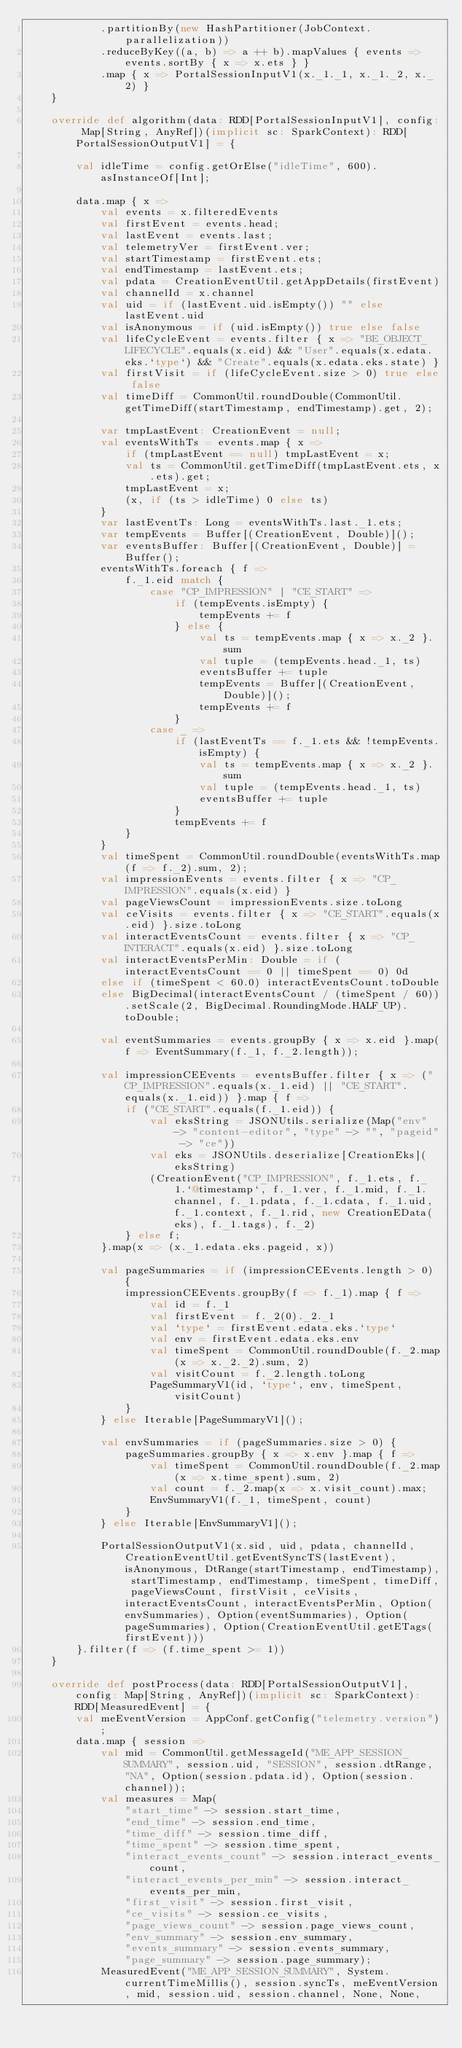Convert code to text. <code><loc_0><loc_0><loc_500><loc_500><_Scala_>            .partitionBy(new HashPartitioner(JobContext.parallelization))
            .reduceByKey((a, b) => a ++ b).mapValues { events => events.sortBy { x => x.ets } }
            .map { x => PortalSessionInputV1(x._1._1, x._1._2, x._2) }
    }

    override def algorithm(data: RDD[PortalSessionInputV1], config: Map[String, AnyRef])(implicit sc: SparkContext): RDD[PortalSessionOutputV1] = {

        val idleTime = config.getOrElse("idleTime", 600).asInstanceOf[Int];

        data.map { x =>
            val events = x.filteredEvents
            val firstEvent = events.head;
            val lastEvent = events.last;
            val telemetryVer = firstEvent.ver;
            val startTimestamp = firstEvent.ets;
            val endTimestamp = lastEvent.ets;
            val pdata = CreationEventUtil.getAppDetails(firstEvent)
            val channelId = x.channel
            val uid = if (lastEvent.uid.isEmpty()) "" else lastEvent.uid
            val isAnonymous = if (uid.isEmpty()) true else false
            val lifeCycleEvent = events.filter { x => "BE_OBJECT_LIFECYCLE".equals(x.eid) && "User".equals(x.edata.eks.`type`) && "Create".equals(x.edata.eks.state) }
            val firstVisit = if (lifeCycleEvent.size > 0) true else false
            val timeDiff = CommonUtil.roundDouble(CommonUtil.getTimeDiff(startTimestamp, endTimestamp).get, 2);

            var tmpLastEvent: CreationEvent = null;
            val eventsWithTs = events.map { x =>
                if (tmpLastEvent == null) tmpLastEvent = x;
                val ts = CommonUtil.getTimeDiff(tmpLastEvent.ets, x.ets).get;
                tmpLastEvent = x;
                (x, if (ts > idleTime) 0 else ts)
            }
            var lastEventTs: Long = eventsWithTs.last._1.ets;
            var tempEvents = Buffer[(CreationEvent, Double)]();
            var eventsBuffer: Buffer[(CreationEvent, Double)] = Buffer();
            eventsWithTs.foreach { f =>
                f._1.eid match {
                    case "CP_IMPRESSION" | "CE_START" =>
                        if (tempEvents.isEmpty) {
                            tempEvents += f
                        } else {
                            val ts = tempEvents.map { x => x._2 }.sum
                            val tuple = (tempEvents.head._1, ts)
                            eventsBuffer += tuple
                            tempEvents = Buffer[(CreationEvent, Double)]();
                            tempEvents += f
                        }
                    case _ =>
                        if (lastEventTs == f._1.ets && !tempEvents.isEmpty) {
                            val ts = tempEvents.map { x => x._2 }.sum
                            val tuple = (tempEvents.head._1, ts)
                            eventsBuffer += tuple
                        }
                        tempEvents += f
                }
            }
            val timeSpent = CommonUtil.roundDouble(eventsWithTs.map(f => f._2).sum, 2);
            val impressionEvents = events.filter { x => "CP_IMPRESSION".equals(x.eid) }
            val pageViewsCount = impressionEvents.size.toLong
            val ceVisits = events.filter { x => "CE_START".equals(x.eid) }.size.toLong
            val interactEventsCount = events.filter { x => "CP_INTERACT".equals(x.eid) }.size.toLong
            val interactEventsPerMin: Double = if (interactEventsCount == 0 || timeSpent == 0) 0d
            else if (timeSpent < 60.0) interactEventsCount.toDouble
            else BigDecimal(interactEventsCount / (timeSpent / 60)).setScale(2, BigDecimal.RoundingMode.HALF_UP).toDouble;

            val eventSummaries = events.groupBy { x => x.eid }.map(f => EventSummary(f._1, f._2.length));

            val impressionCEEvents = eventsBuffer.filter { x => ("CP_IMPRESSION".equals(x._1.eid) || "CE_START".equals(x._1.eid)) }.map { f =>
                if ("CE_START".equals(f._1.eid)) {
                    val eksString = JSONUtils.serialize(Map("env" -> "content-editor", "type" -> "", "pageid" -> "ce"))
                    val eks = JSONUtils.deserialize[CreationEks](eksString)
                    (CreationEvent("CP_IMPRESSION", f._1.ets, f._1.`@timestamp`, f._1.ver, f._1.mid, f._1.channel, f._1.pdata, f._1.cdata, f._1.uid, f._1.context, f._1.rid, new CreationEData(eks), f._1.tags), f._2)
                } else f;
            }.map(x => (x._1.edata.eks.pageid, x))

            val pageSummaries = if (impressionCEEvents.length > 0) {
                impressionCEEvents.groupBy(f => f._1).map { f =>
                    val id = f._1
                    val firstEvent = f._2(0)._2._1
                    val `type` = firstEvent.edata.eks.`type`
                    val env = firstEvent.edata.eks.env
                    val timeSpent = CommonUtil.roundDouble(f._2.map(x => x._2._2).sum, 2)
                    val visitCount = f._2.length.toLong
                    PageSummaryV1(id, `type`, env, timeSpent, visitCount)
                }
            } else Iterable[PageSummaryV1]();

            val envSummaries = if (pageSummaries.size > 0) {
                pageSummaries.groupBy { x => x.env }.map { f =>
                    val timeSpent = CommonUtil.roundDouble(f._2.map(x => x.time_spent).sum, 2)
                    val count = f._2.map(x => x.visit_count).max;
                    EnvSummaryV1(f._1, timeSpent, count)
                }
            } else Iterable[EnvSummaryV1]();

            PortalSessionOutputV1(x.sid, uid, pdata, channelId, CreationEventUtil.getEventSyncTS(lastEvent), isAnonymous, DtRange(startTimestamp, endTimestamp), startTimestamp, endTimestamp, timeSpent, timeDiff, pageViewsCount, firstVisit, ceVisits, interactEventsCount, interactEventsPerMin, Option(envSummaries), Option(eventSummaries), Option(pageSummaries), Option(CreationEventUtil.getETags(firstEvent)))
        }.filter(f => (f.time_spent >= 1))
    }

    override def postProcess(data: RDD[PortalSessionOutputV1], config: Map[String, AnyRef])(implicit sc: SparkContext): RDD[MeasuredEvent] = {
        val meEventVersion = AppConf.getConfig("telemetry.version");
        data.map { session =>
            val mid = CommonUtil.getMessageId("ME_APP_SESSION_SUMMARY", session.uid, "SESSION", session.dtRange, "NA", Option(session.pdata.id), Option(session.channel));
            val measures = Map(
                "start_time" -> session.start_time,
                "end_time" -> session.end_time,
                "time_diff" -> session.time_diff,
                "time_spent" -> session.time_spent,
                "interact_events_count" -> session.interact_events_count,
                "interact_events_per_min" -> session.interact_events_per_min,
                "first_visit" -> session.first_visit,
                "ce_visits" -> session.ce_visits,
                "page_views_count" -> session.page_views_count,
                "env_summary" -> session.env_summary,
                "events_summary" -> session.events_summary,
                "page_summary" -> session.page_summary);
            MeasuredEvent("ME_APP_SESSION_SUMMARY", System.currentTimeMillis(), session.syncTs, meEventVersion, mid, session.uid, session.channel, None, None,</code> 